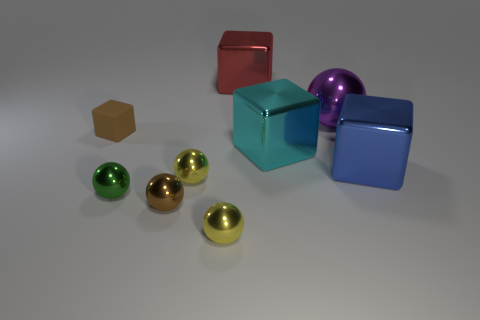Are there any other things that are the same color as the big metal sphere?
Offer a terse response. No. Is the material of the red object the same as the purple ball?
Your answer should be compact. Yes. Are there the same number of cyan things on the left side of the red shiny cube and tiny yellow things that are on the right side of the cyan block?
Your answer should be very brief. Yes. There is a brown object that is the same shape as the green metallic thing; what is it made of?
Give a very brief answer. Metal. There is a yellow metal object to the left of the sphere that is in front of the brown object in front of the small matte object; what is its shape?
Provide a succinct answer. Sphere. Are there more brown objects in front of the tiny rubber block than big gray metal blocks?
Offer a very short reply. Yes. There is a small yellow object that is in front of the brown metallic sphere; does it have the same shape as the large cyan shiny thing?
Your response must be concise. No. What material is the tiny thing that is to the left of the small green metal thing?
Your answer should be compact. Rubber. How many yellow things have the same shape as the small green metallic thing?
Offer a very short reply. 2. There is a sphere on the right side of the tiny metallic object that is in front of the brown shiny thing; what is its material?
Your answer should be compact. Metal. 